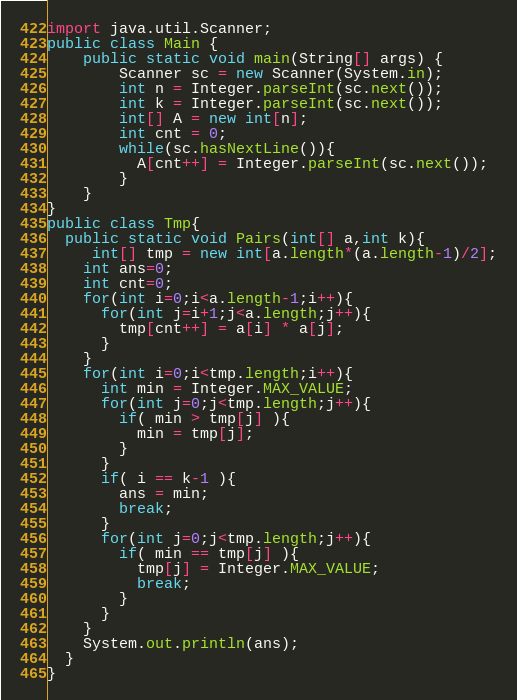Convert code to text. <code><loc_0><loc_0><loc_500><loc_500><_Java_>import java.util.Scanner;
public class Main {
    public static void main(String[] args) {
     	Scanner sc = new Scanner(System.in);
		int n = Integer.parseInt(sc.next());
      	int k = Integer.parseInt(sc.next());
        int[] A = new int[n];
        int cnt = 0;
      	while(sc.hasNextLine()){
          A[cnt++] = Integer.parseInt(sc.next());
        }
    }
}
public class Tmp{
  public static void Pairs(int[] a,int k){
     int[] tmp = new int[a.length*(a.length-1)/2];
    int ans=0;
    int cnt=0;
    for(int i=0;i<a.length-1;i++){
      for(int j=i+1;j<a.length;j++){
        tmp[cnt++] = a[i] * a[j];
      }
    }
    for(int i=0;i<tmp.length;i++){
      int min = Integer.MAX_VALUE;
      for(int j=0;j<tmp.length;j++){
        if( min > tmp[j] ){
          min = tmp[j];
        }
      }
      if( i == k-1 ){
        ans = min;
        break;
      }
      for(int j=0;j<tmp.length;j++){
        if( min == tmp[j] ){
          tmp[j] = Integer.MAX_VALUE;
          break;
        }
      }
    }
    System.out.println(ans);
  }
}</code> 